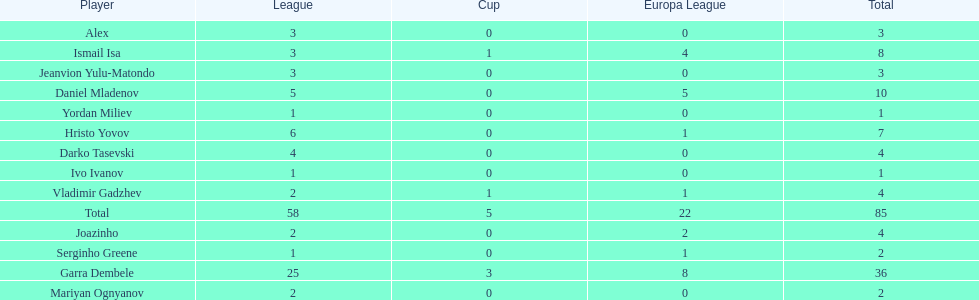Which total is higher, the europa league total or the league total? League. 